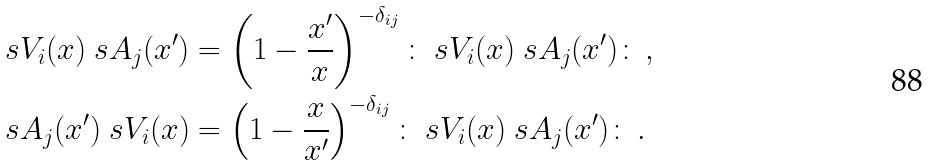<formula> <loc_0><loc_0><loc_500><loc_500>\ s V _ { i } ( x ) \ s A _ { j } ( x ^ { \prime } ) & = \left ( 1 - \frac { x ^ { \prime } } { x } \right ) ^ { - \delta _ { i j } } \colon \ s V _ { i } ( x ) \ s A _ { j } ( x ^ { \prime } ) \colon \, , \\ \ s A _ { j } ( x ^ { \prime } ) \ s V _ { i } ( x ) & = \left ( 1 - \frac { x } { x ^ { \prime } } \right ) ^ { - \delta _ { i j } } \colon \ s V _ { i } ( x ) \ s A _ { j } ( x ^ { \prime } ) \colon \, .</formula> 